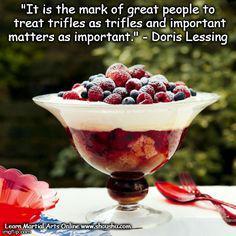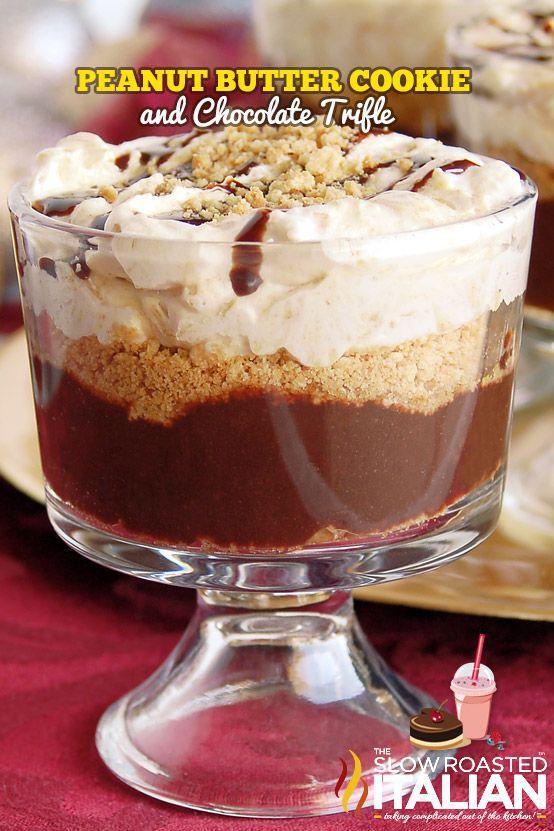The first image is the image on the left, the second image is the image on the right. Considering the images on both sides, is "One image shows a large layered dessert in a clear footed bowl, topped with a thick creamy layer and a garnish of the same items used in a lower layer." valid? Answer yes or no. Yes. The first image is the image on the left, the second image is the image on the right. Considering the images on both sides, is "A dessert in a footed glass has a neat row of berries around the rim for garnish." valid? Answer yes or no. No. 